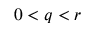<formula> <loc_0><loc_0><loc_500><loc_500>0 < q < r</formula> 